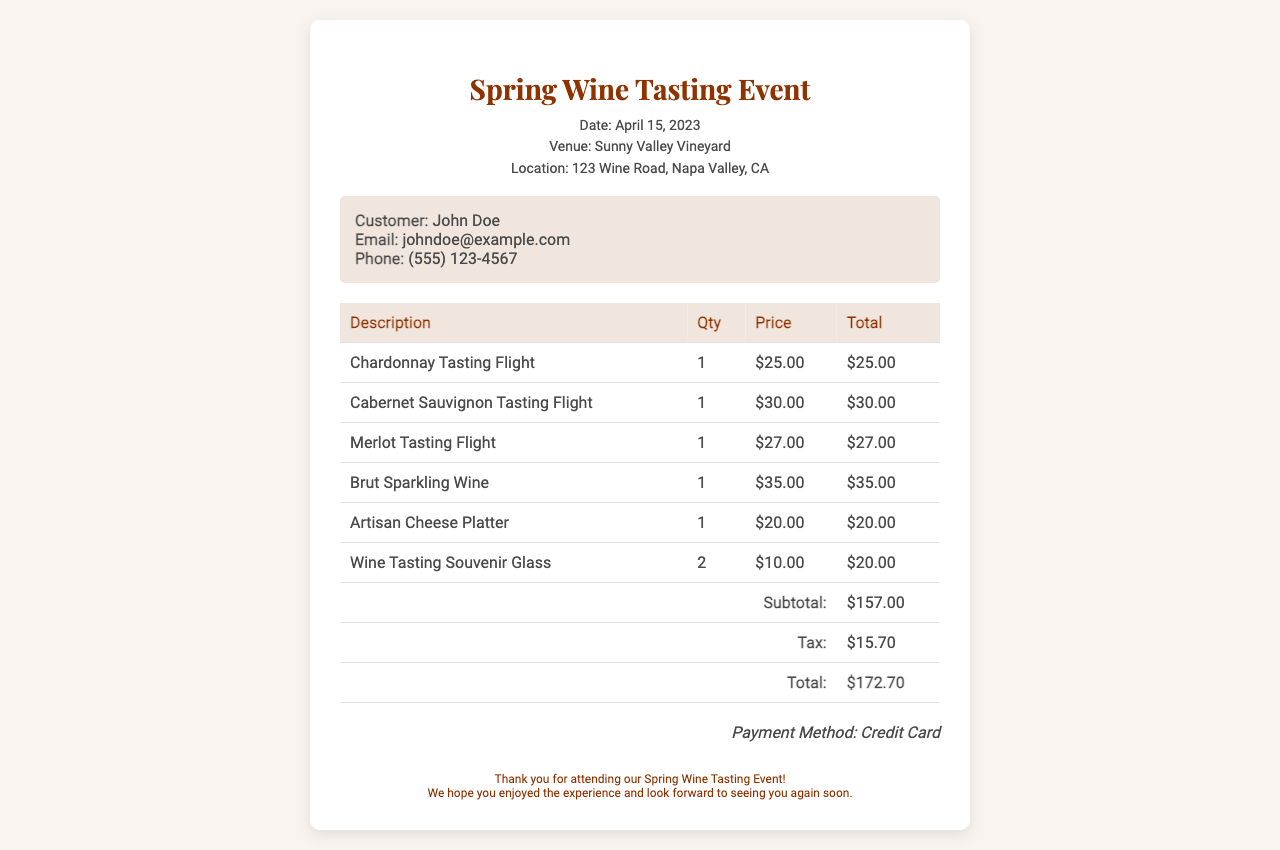What is the date of the event? The date of the event is mentioned in the header section of the document.
Answer: April 15, 2023 What is the total amount of the receipt? The total amount is calculated at the end of the itemized selections section in the document.
Answer: $172.70 How many Wine Tasting Souvenir Glasses were purchased? The quantity of Wine Tasting Souvenir Glasses is listed in the itemized selection table.
Answer: 2 What is the price of the Cabernet Sauvignon Tasting Flight? The price for Cabernet Sauvignon Tasting Flight can be found in the itemized selections section.
Answer: $30.00 What payment method was used? The payment method is mentioned at the bottom of the receipt.
Answer: Credit Card What is the subtotal before tax? The subtotal before tax is given in the breakdown of the costs in the itemized table.
Answer: $157.00 What is included in the customer details? The customer details section contains name, email, and phone number.
Answer: John Doe, johndoe@example.com, (555) 123-4567 Where is the event located? The location of the event is stated in the event details section of the document.
Answer: 123 Wine Road, Napa Valley, CA What type of event is this receipt for? The type of event is indicated in the header section of the document.
Answer: Wine Tasting Event 